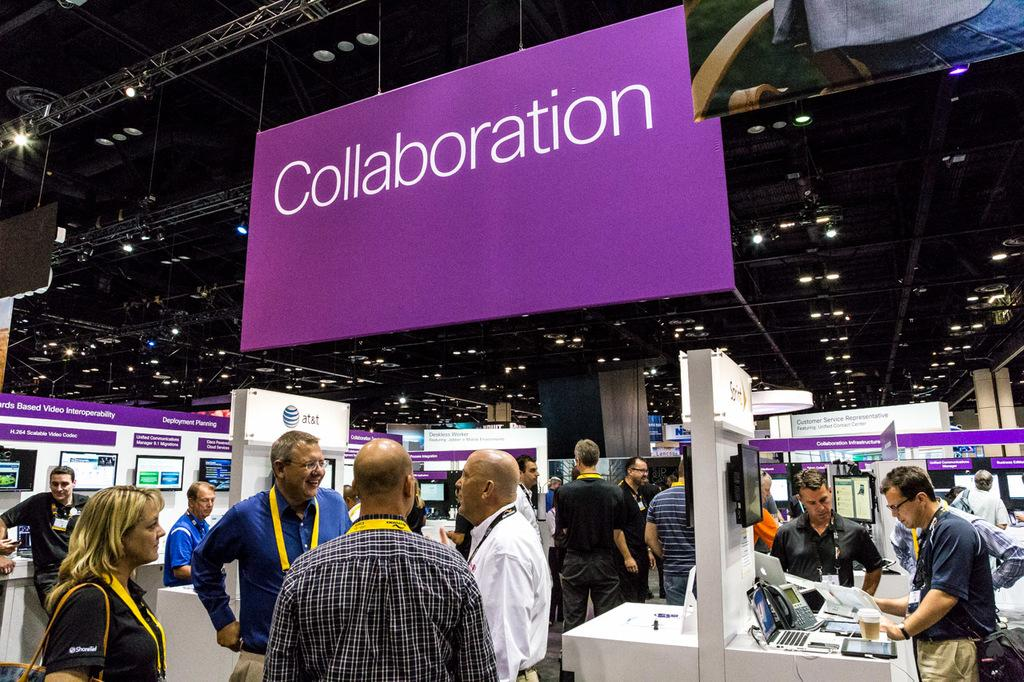<image>
Summarize the visual content of the image. Collaboration is written on a purple banner hanging at a conference 